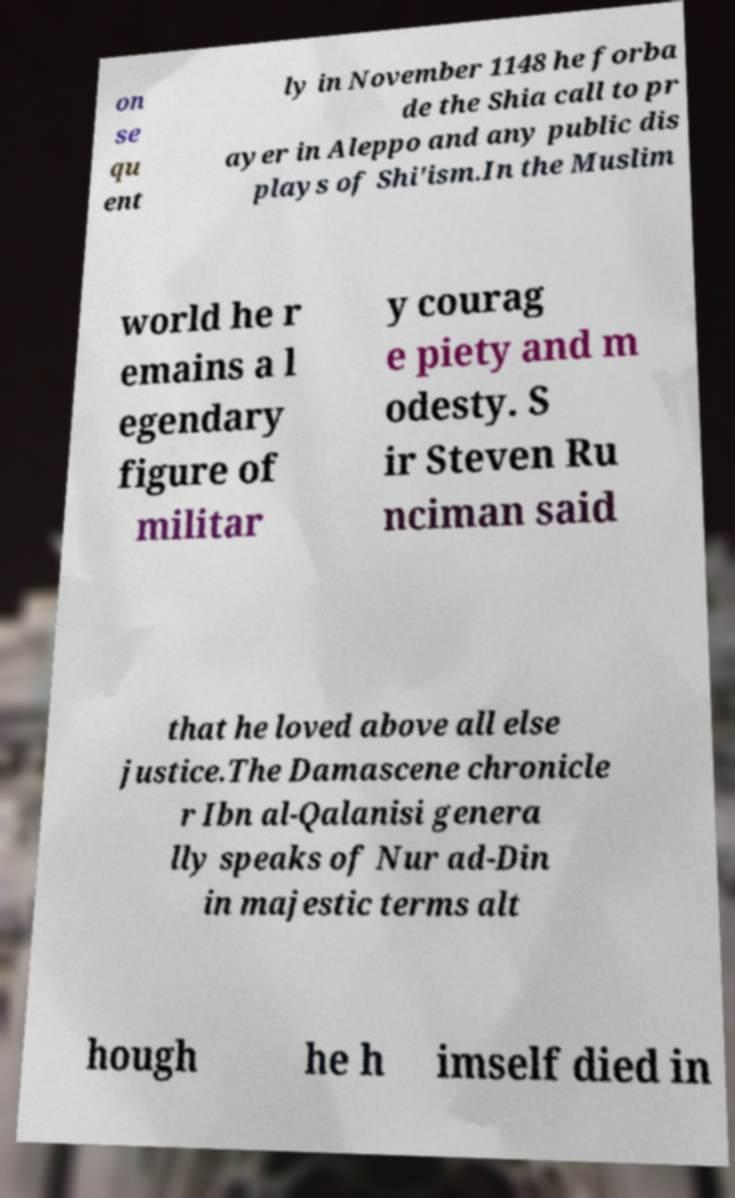What messages or text are displayed in this image? I need them in a readable, typed format. on se qu ent ly in November 1148 he forba de the Shia call to pr ayer in Aleppo and any public dis plays of Shi'ism.In the Muslim world he r emains a l egendary figure of militar y courag e piety and m odesty. S ir Steven Ru nciman said that he loved above all else justice.The Damascene chronicle r Ibn al-Qalanisi genera lly speaks of Nur ad-Din in majestic terms alt hough he h imself died in 